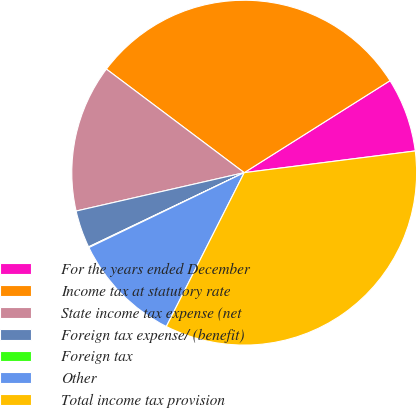Convert chart to OTSL. <chart><loc_0><loc_0><loc_500><loc_500><pie_chart><fcel>For the years ended December<fcel>Income tax at statutory rate<fcel>State income tax expense (net<fcel>Foreign tax expense/ (benefit)<fcel>Foreign tax<fcel>Other<fcel>Total income tax provision<nl><fcel>6.95%<fcel>30.79%<fcel>13.83%<fcel>3.51%<fcel>0.07%<fcel>10.39%<fcel>34.47%<nl></chart> 